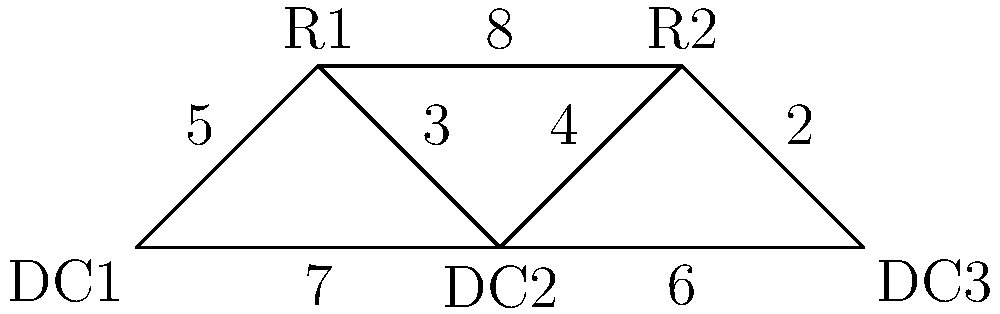Given the supply chain network diagram above, where DC represents distribution centers and R represents retailers, what is the shortest path from DC1 to DC3? Provide the route and total distance. To find the shortest path from DC1 to DC3, we need to consider all possible routes and calculate their total distances:

1. DC1 -> R1 -> DC2 -> R2 -> DC3
   Distance: 5 + 3 + 4 + 2 = 14

2. DC1 -> R1 -> R2 -> DC3
   Distance: 5 + 8 + 2 = 15

3. DC1 -> DC2 -> R2 -> DC3
   Distance: 7 + 4 + 2 = 13

4. DC1 -> DC2 -> DC3
   Distance: 7 + 6 = 13

Comparing the total distances, we can see that there are two routes with the shortest distance of 13:
- DC1 -> DC2 -> R2 -> DC3
- DC1 -> DC2 -> DC3

However, the question asks for the shortest path, so we should choose the route with fewer stops. Therefore, the optimal route is DC1 -> DC2 -> DC3.
Answer: DC1 -> DC2 -> DC3; 13 units 